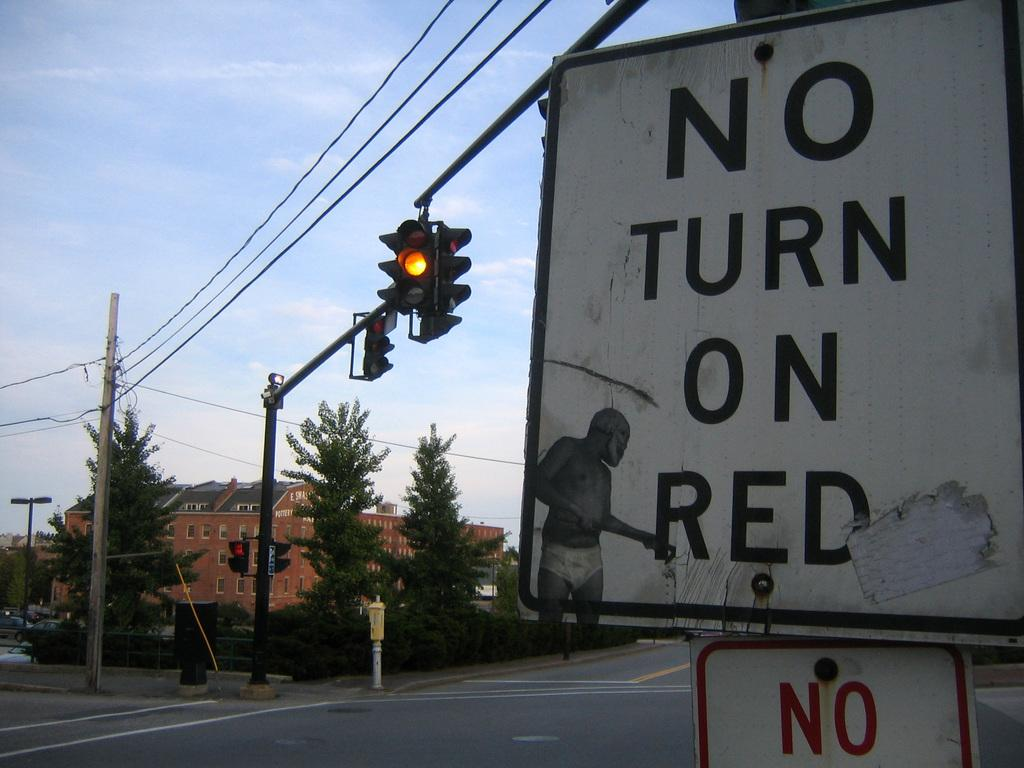<image>
Offer a succinct explanation of the picture presented. A yellow light with a sign that states no turn on red. 